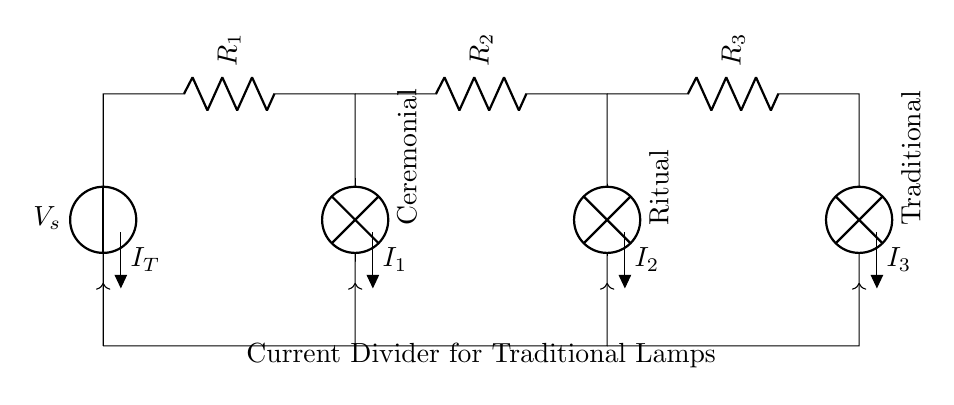What is the source voltage in this circuit? The source voltage is indicated by V_s, which is a standard notation for the voltage source in the circuit.
Answer: V_s What is the total current entering the circuit? The total current entering the circuit is labeled as I_T, representing the total current supplied by the voltage source.
Answer: I_T How many lamps are present in the circuit? By examining the circuit, we can count the number of lamp symbols, which represent the loads in the circuit. There are three distinct lamp components shown.
Answer: Three What type of circuit configuration is used here? The circuit configuration is a current divider, where the primary current from the source splits to power multiple branches connected to lamps.
Answer: Current divider What is the function of resistors R_1, R_2, and R_3 in this circuit? The resistors R_1, R_2, and R_3 limit the current flowing through each respective lamp. Each resistor has a specific resistance value that affects how much current each lamp receives.
Answer: Limit current If the current through R_1 is I_1, what can be said about I_2 and I_3 in relation to I_T? In a current divider, the sum of the currents through all branches equals the total current entering the circuit. Thus, I_T equals I_1 plus I_2 plus I_3, following Kirchhoff's Current Law.
Answer: I_T = I_1 + I_2 + I_3 What determines the brightness of each lamp in this circuit? The brightness of each lamp is determined by the amount of current passing through each lamp, which is affected by the resistance values of R_1, R_2, and R_3 within the current divider arrangement.
Answer: Current through lamps 